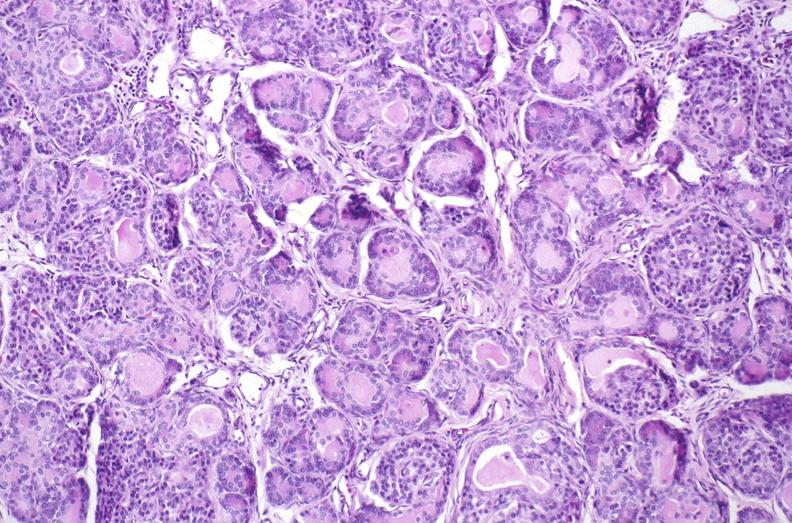does this image show cystic fibrosis?
Answer the question using a single word or phrase. Yes 